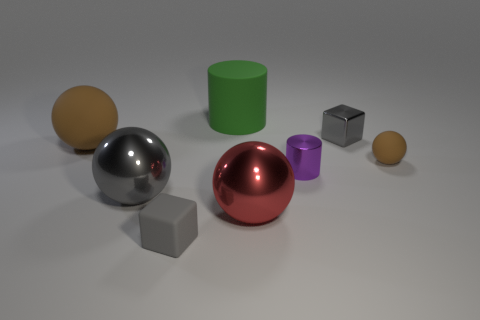Subtract all big balls. How many balls are left? 1 Add 1 yellow metallic objects. How many objects exist? 9 Subtract all red balls. How many balls are left? 3 Subtract all cylinders. How many objects are left? 6 Subtract 1 cylinders. How many cylinders are left? 1 Subtract all green cylinders. Subtract all gray cubes. How many cylinders are left? 1 Subtract all gray cylinders. How many cyan balls are left? 0 Subtract all big green objects. Subtract all tiny metal cubes. How many objects are left? 6 Add 5 tiny brown spheres. How many tiny brown spheres are left? 6 Add 6 gray balls. How many gray balls exist? 7 